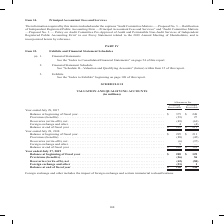According to Cisco Systems's financial document, What did foreign exchange and other include? the impact of foreign exchange and certain immaterial reclassifications.. The document states: "Foreign exchange and other includes the impact of foreign exchange and certain immaterial reclassifications...." Also, Which fiscal years does the table provide information for the company's valuation and qualifying accounts? The document contains multiple relevant values: 2019, 2018, 2017. From the document: "ceivables Accounts Receivable Year ended July 29, 2017 Balance at beginning of fiscal year . $ 375 $ 249 Provisions (benefits) . (35) 27 Recoveries (w..." Also, What was the balance at beginning of fiscal year in 2017 for allowances for financing receivables? According to the financial document, 375 (in millions). The relevant text states: "29, 2017 Balance at beginning of fiscal year . $ 375 $ 249 Provisions (benefits) . (35) 27 Recoveries (write-offs), net . (49) (61) Foreign exchange and..." Also, can you calculate: What was the change in the provisions for accounts receivables between 2017 and 2018? Based on the calculation: -45-27, the result is -72 (in millions). This is based on the information: "year . $ 295 $ 211 Provisions (benefits) . (89) (45) Recoveries (write-offs), net . (6) (37) Foreign exchange and other . 5 — Balance at end of fiscal l year . $ 375 $ 249 Provisions (benefits) . (35)..." The key data points involved are: 27, 45. Also, can you calculate: What was the change in the Financing Receivables for Foreign exchange and other between 2017 and 2019? Based on the calculation: -21-4, the result is -25 (in millions). This is based on the information: "s), net . (42) (50) Foreign exchange and other . (21) 1 Balance at end of fiscal year . $ 126 $ 136 s), net . (42) (50) Foreign exchange and other . (21) 1 Balance at end of fiscal year . $ 126 $ 136..." The key data points involved are: 21, 4. Also, can you calculate: What was the percentage change in the balance at the end of fiscal year for financing receivables between 2018 and 2019? To answer this question, I need to perform calculations using the financial data. The calculation is: (126-205)/205, which equals -38.54 (percentage). This is based on the information: "and other . 5 — Balance at end of fiscal year . $ 205 $ 129 Year ended July 27, 2019 Balance at beginning of fiscal year . $ 205 $ 129 Provisions (benefi other . (21) 1 Balance at end of fiscal year ...." The key data points involved are: 126, 205. 